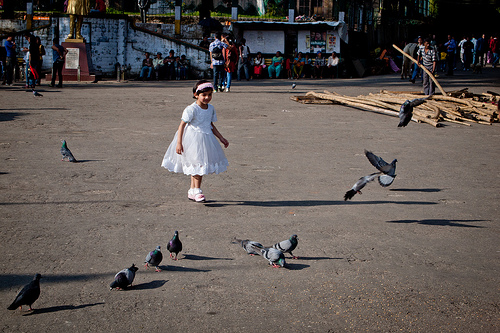<image>
Is there a pigeon to the left of the girl? No. The pigeon is not to the left of the girl. From this viewpoint, they have a different horizontal relationship. 